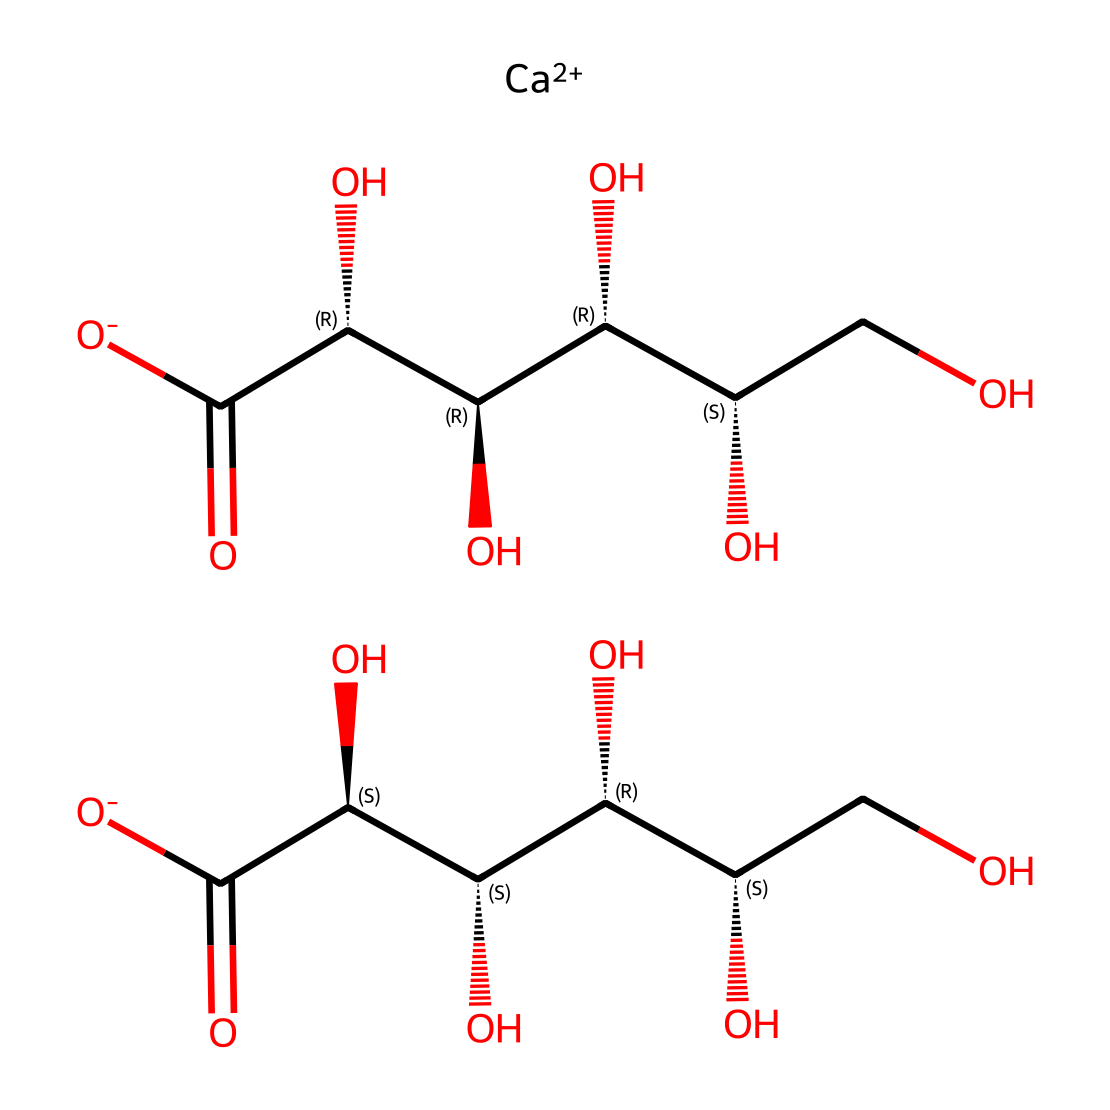What is the main cation in calcium gluconate? The SMILES representation indicates the presence of [Ca++], which represents calcium ions as the main cation in the structure.
Answer: calcium How many hydroxyl groups are present in calcium gluconate? Looking at the chemical structure, there are four hydroxyl (–OH) groups indicated by the "O" atoms that are connected to carbon atoms, typically for each glucose moiety.
Answer: four What is the total number of carbon atoms in calcium gluconate? In the SMILES structure, upon counting the "C" symbols, there are a total of 10 carbon atoms in the molecular arrangement.
Answer: ten What is the primary function of calcium gluconate when used as an electrolyte? Calcium gluconate provides a source of calcium which is crucial for various physiological functions in the body such as nerve transmission and muscle contraction.
Answer: hydration What type of molecular arrangement is indicated by the chirality symbols in the SMILES? The chirality symbols "@", which indicate stereocenters, suggest that the molecule has a chiral arrangement that can exist in multiple stereoisomer forms.
Answer: chiral How does the presence of carboxylate groups influence the solubility of calcium gluconate? The presence of carboxylate groups (-COO-) increases the solubility of calcium gluconate in water due to their ability to interact with water molecules, thus enhancing hydration.
Answer: enhances solubility 